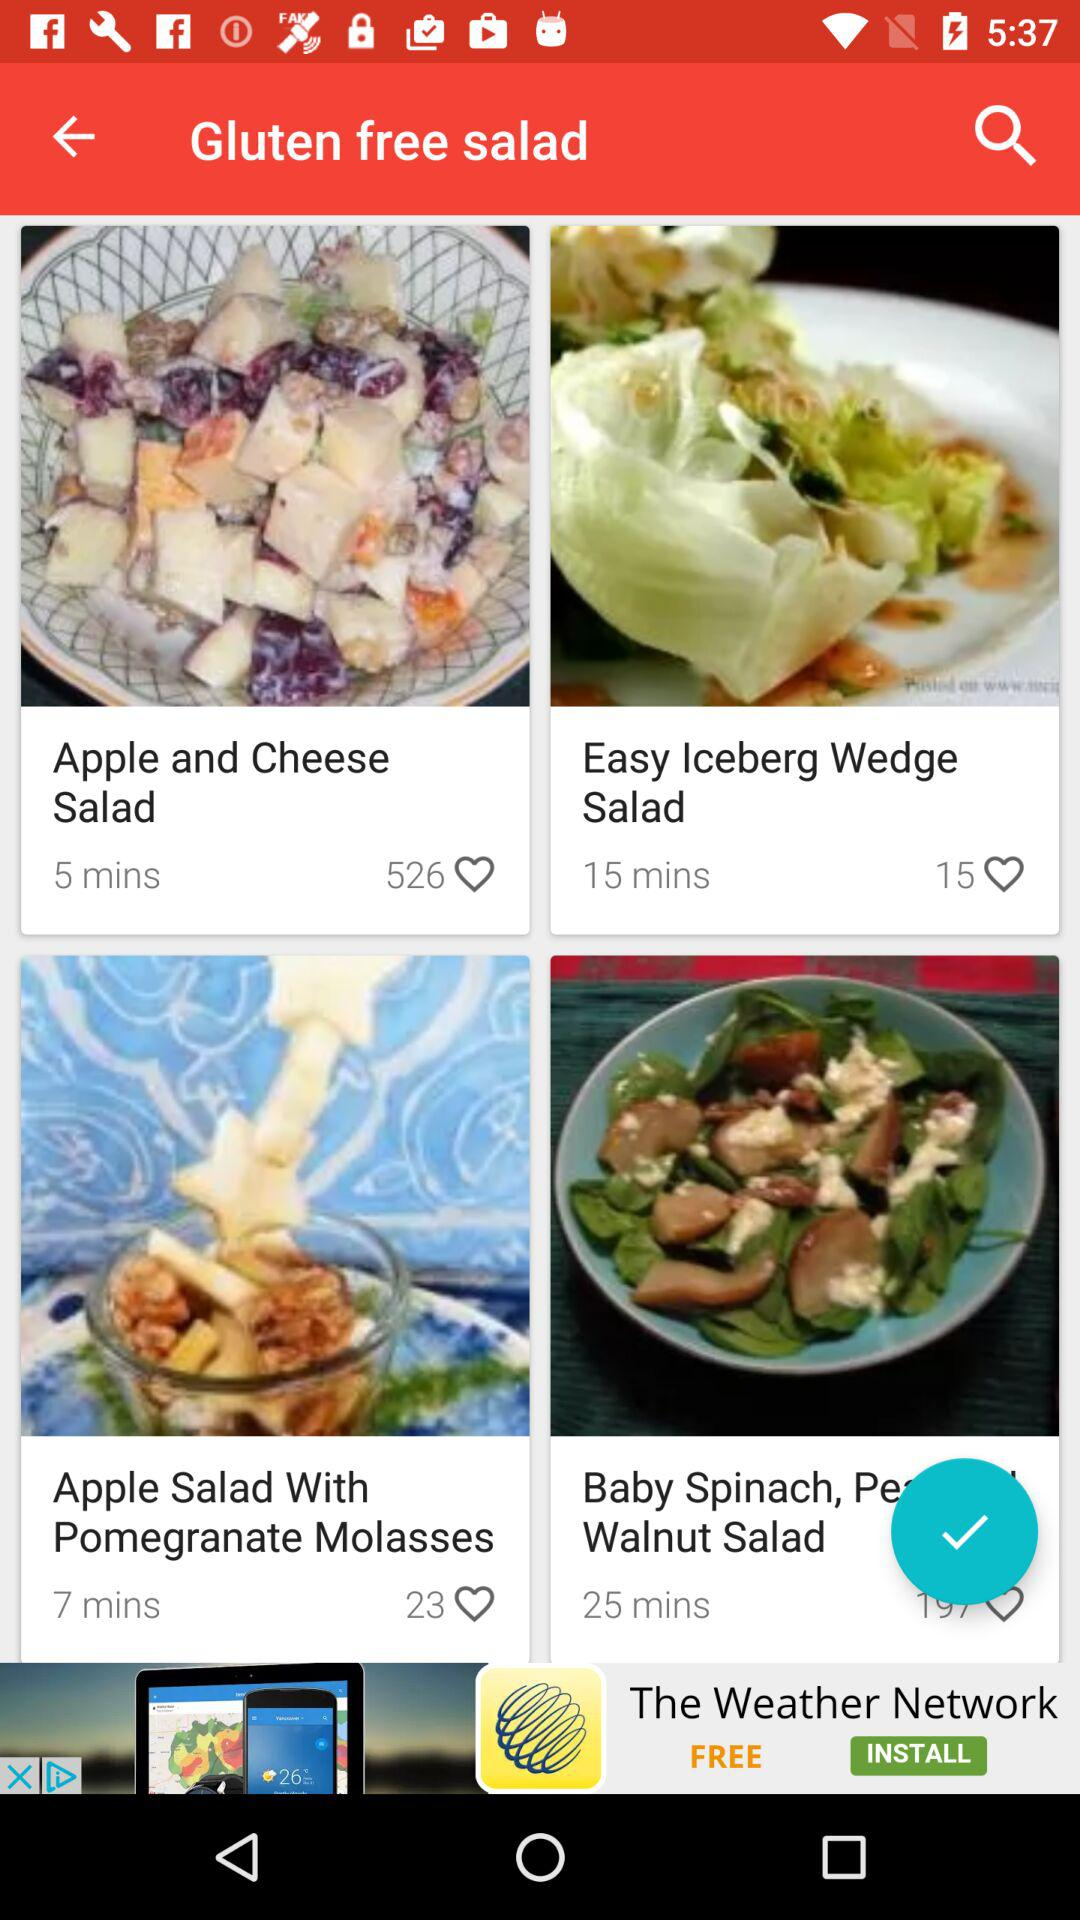What is the number of likes on "Apple and Cheese Salad"? The number of likes on "Apple and Cheese Salad" is 526. 